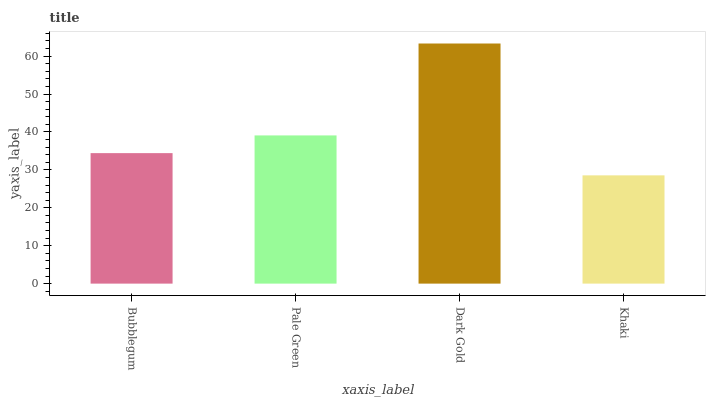Is Pale Green the minimum?
Answer yes or no. No. Is Pale Green the maximum?
Answer yes or no. No. Is Pale Green greater than Bubblegum?
Answer yes or no. Yes. Is Bubblegum less than Pale Green?
Answer yes or no. Yes. Is Bubblegum greater than Pale Green?
Answer yes or no. No. Is Pale Green less than Bubblegum?
Answer yes or no. No. Is Pale Green the high median?
Answer yes or no. Yes. Is Bubblegum the low median?
Answer yes or no. Yes. Is Dark Gold the high median?
Answer yes or no. No. Is Khaki the low median?
Answer yes or no. No. 